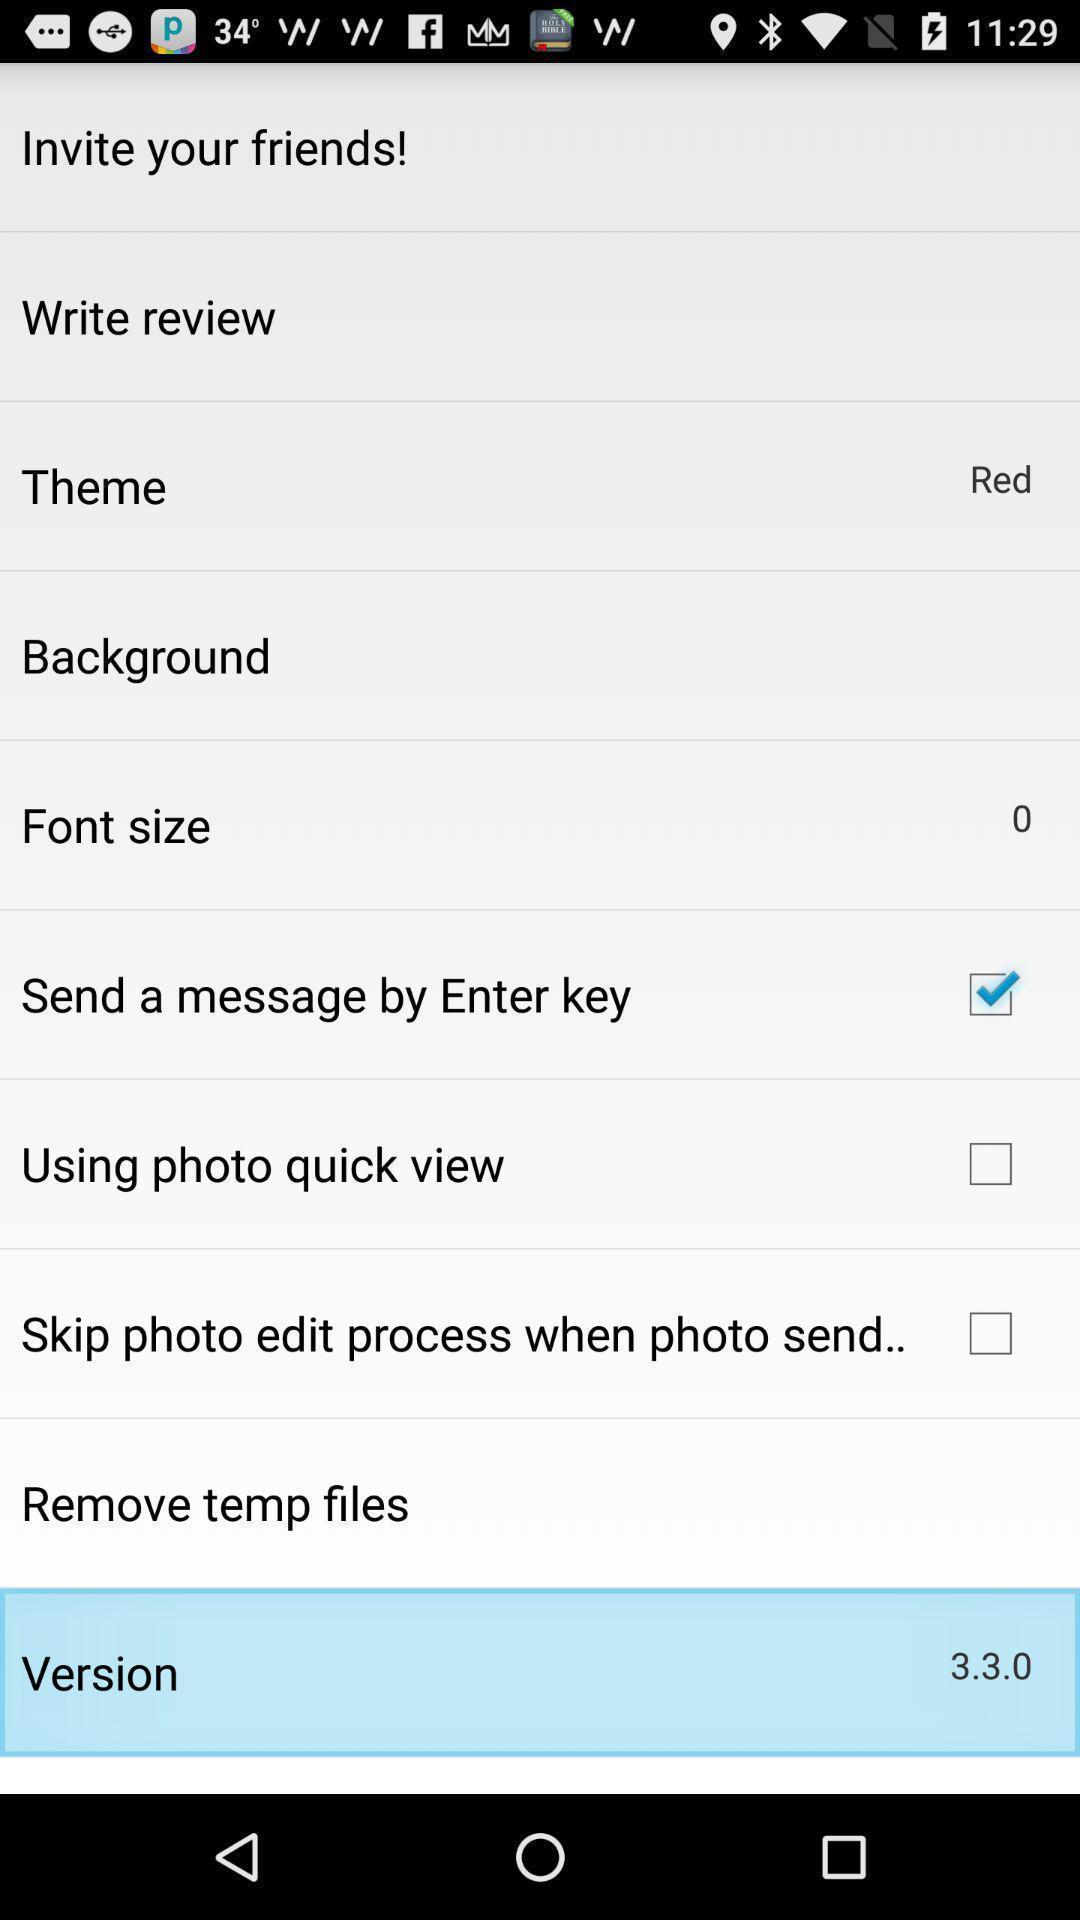Tell me about the visual elements in this screen capture. Page displaying version of the phone. 